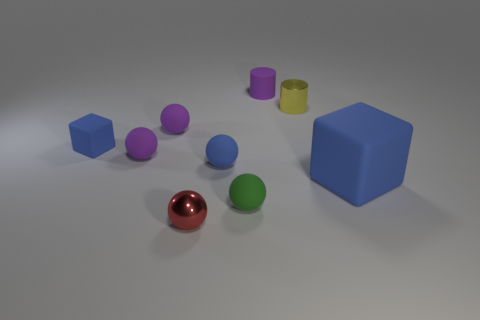Is the big cube the same color as the small block?
Offer a very short reply. Yes. Is the number of small matte spheres less than the number of green spheres?
Your answer should be very brief. No. What number of other objects are the same color as the tiny rubber cylinder?
Make the answer very short. 2. What number of red metal balls are there?
Provide a succinct answer. 1. Is the number of small blocks that are on the right side of the blue matte ball less than the number of purple shiny blocks?
Keep it short and to the point. No. Are the object that is in front of the green rubber thing and the green sphere made of the same material?
Your answer should be compact. No. What is the shape of the tiny metal thing in front of the cube that is behind the blue matte cube on the right side of the tiny purple cylinder?
Keep it short and to the point. Sphere. Are there any blue balls that have the same size as the yellow object?
Your answer should be compact. Yes. The red object has what size?
Offer a very short reply. Small. What number of things are the same size as the shiny sphere?
Offer a very short reply. 7. 